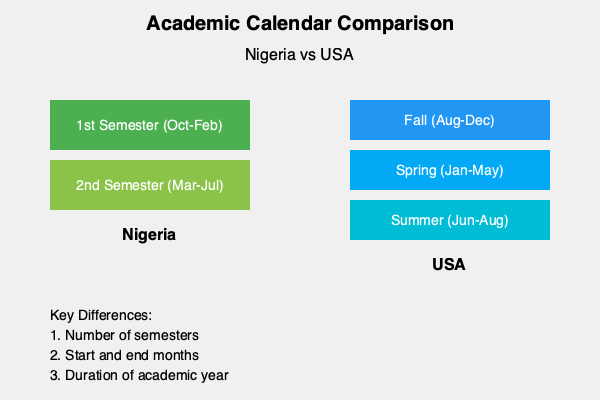Based on the chart comparing academic calendars between Nigerian and American universities, what is the main structural difference in the semester system? To identify the main structural difference in the semester system between Nigerian and American universities, let's analyze the chart step-by-step:

1. Nigerian Academic Calendar:
   - Shows two semesters: 1st Semester (October to February) and 2nd Semester (March to July)
   - Total of 2 semesters per academic year

2. American Academic Calendar:
   - Shows three terms: Fall (August to December), Spring (January to May), and Summer (June to August)
   - Total of 3 terms per academic year

3. Comparison:
   - The Nigerian system operates on a two-semester structure
   - The American system typically follows a three-term structure (two main semesters plus a summer term)

4. Main Structural Difference:
   - The primary difference is the number of academic periods per year
   - Nigeria has 2 semesters, while the USA has 3 terms (including the summer term)

Therefore, the main structural difference in the semester system between Nigerian and American universities is the number of academic periods per year.
Answer: Number of academic periods per year (2 in Nigeria vs. 3 in USA) 